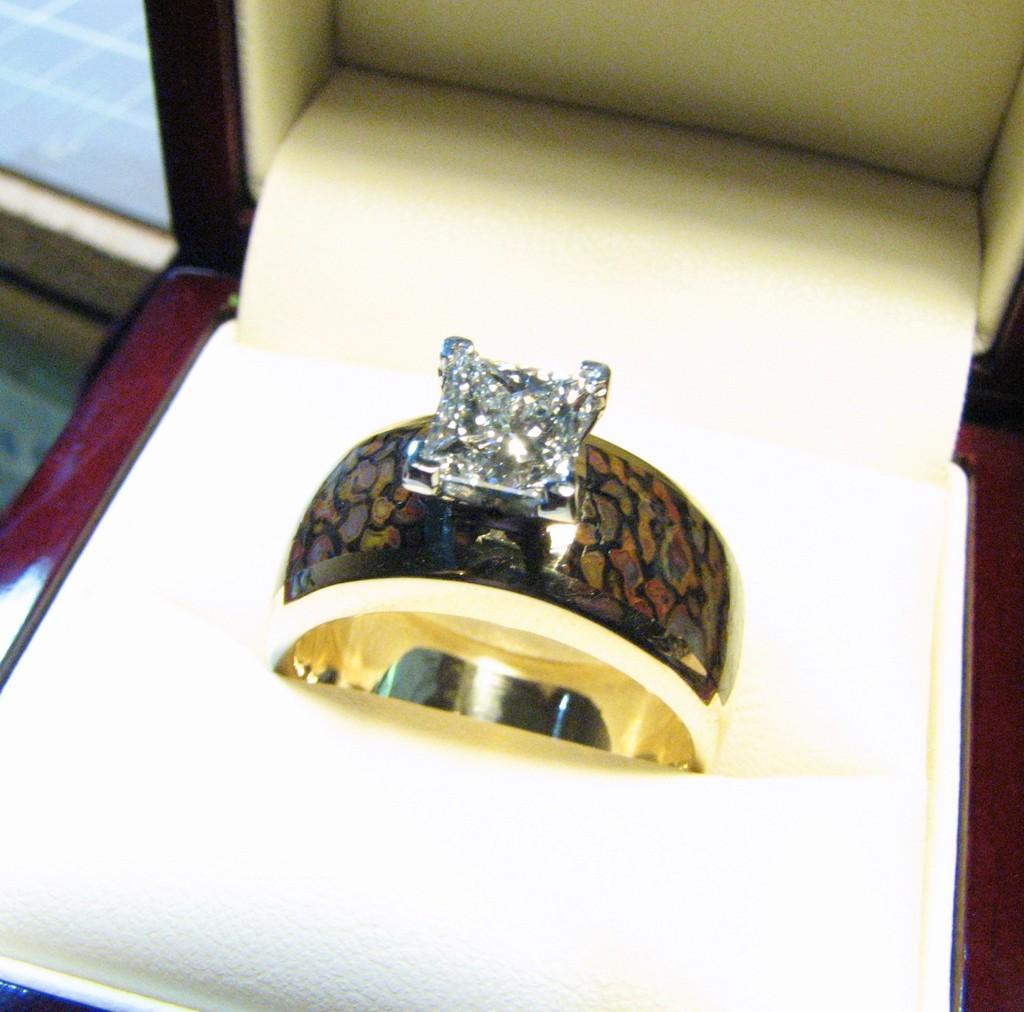How would you summarize this image in a sentence or two? In this image, this looks like a ring. This looks like a diamond stone. I think this is the box. 